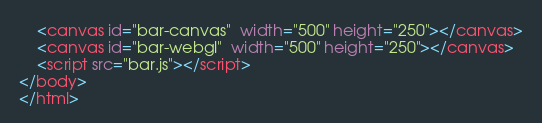Convert code to text. <code><loc_0><loc_0><loc_500><loc_500><_HTML_>    <canvas id="bar-canvas"  width="500" height="250"></canvas>
    <canvas id="bar-webgl"  width="500" height="250"></canvas>
    <script src="bar.js"></script>
</body>
</html>
</code> 